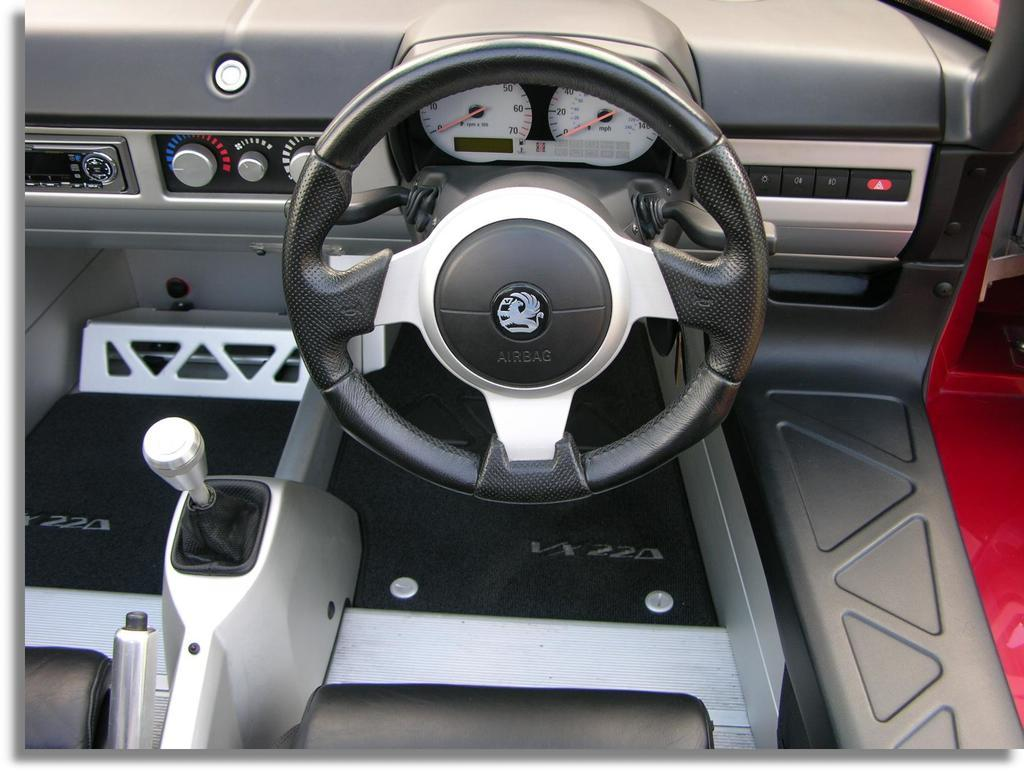What type of location is depicted in the image? The image is inside a vehicle. What is the main control device in the vehicle? There is a steering wheel in the image. What information is displayed in the image? There are meter readings in the image. What is used to change gears in the vehicle? There is a gear rod in the image. How many rings are visible on the gear rod in the image? There are no rings visible on the gear rod in the image. What type of group is shown gathering around the vehicle in the image? There is no group gathering around the vehicle in the image. 